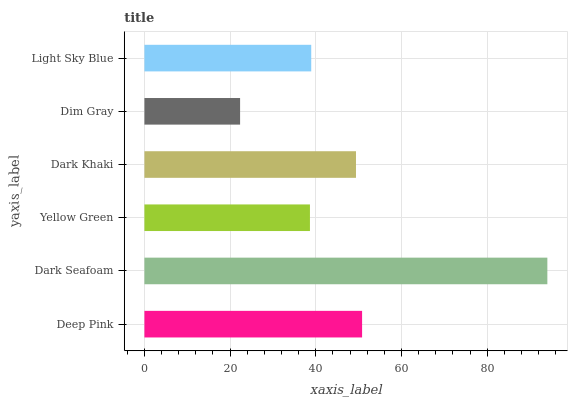Is Dim Gray the minimum?
Answer yes or no. Yes. Is Dark Seafoam the maximum?
Answer yes or no. Yes. Is Yellow Green the minimum?
Answer yes or no. No. Is Yellow Green the maximum?
Answer yes or no. No. Is Dark Seafoam greater than Yellow Green?
Answer yes or no. Yes. Is Yellow Green less than Dark Seafoam?
Answer yes or no. Yes. Is Yellow Green greater than Dark Seafoam?
Answer yes or no. No. Is Dark Seafoam less than Yellow Green?
Answer yes or no. No. Is Dark Khaki the high median?
Answer yes or no. Yes. Is Light Sky Blue the low median?
Answer yes or no. Yes. Is Dim Gray the high median?
Answer yes or no. No. Is Dim Gray the low median?
Answer yes or no. No. 